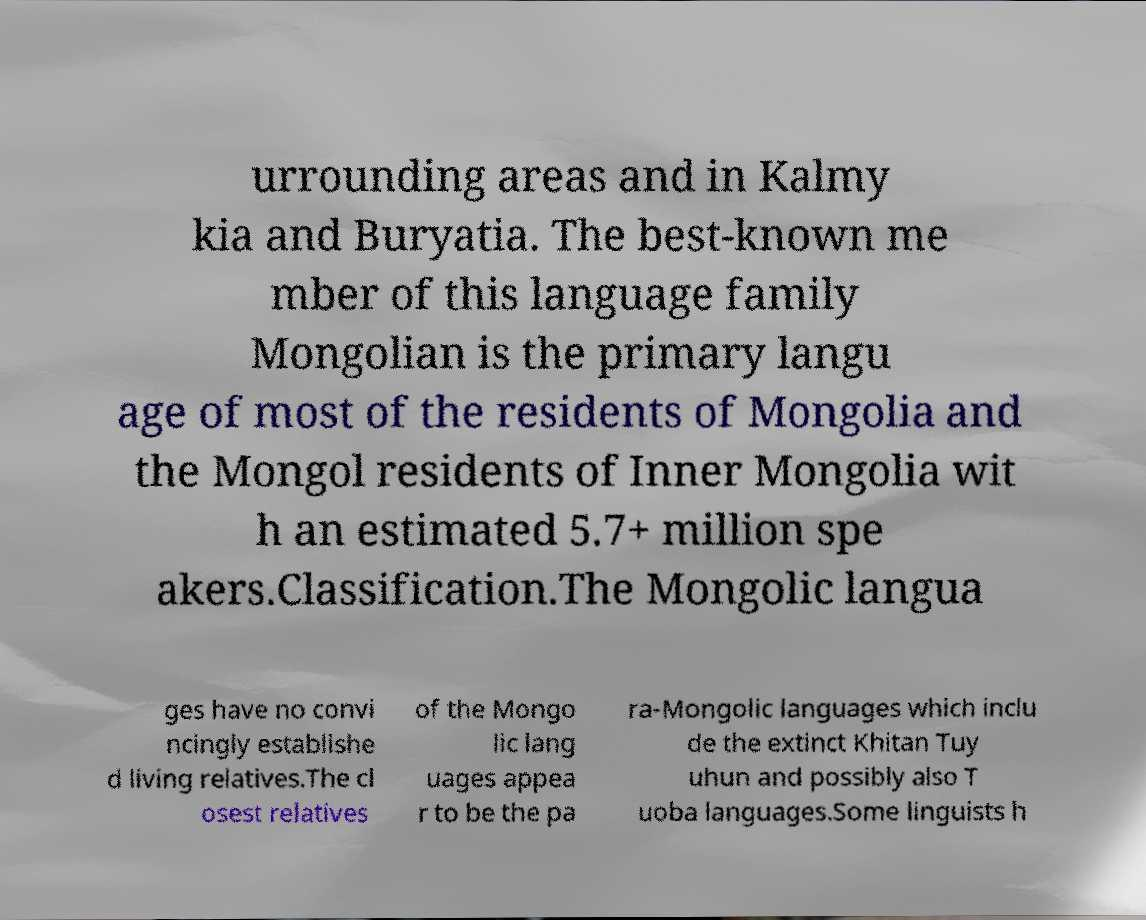Can you accurately transcribe the text from the provided image for me? urrounding areas and in Kalmy kia and Buryatia. The best-known me mber of this language family Mongolian is the primary langu age of most of the residents of Mongolia and the Mongol residents of Inner Mongolia wit h an estimated 5.7+ million spe akers.Classification.The Mongolic langua ges have no convi ncingly establishe d living relatives.The cl osest relatives of the Mongo lic lang uages appea r to be the pa ra-Mongolic languages which inclu de the extinct Khitan Tuy uhun and possibly also T uoba languages.Some linguists h 